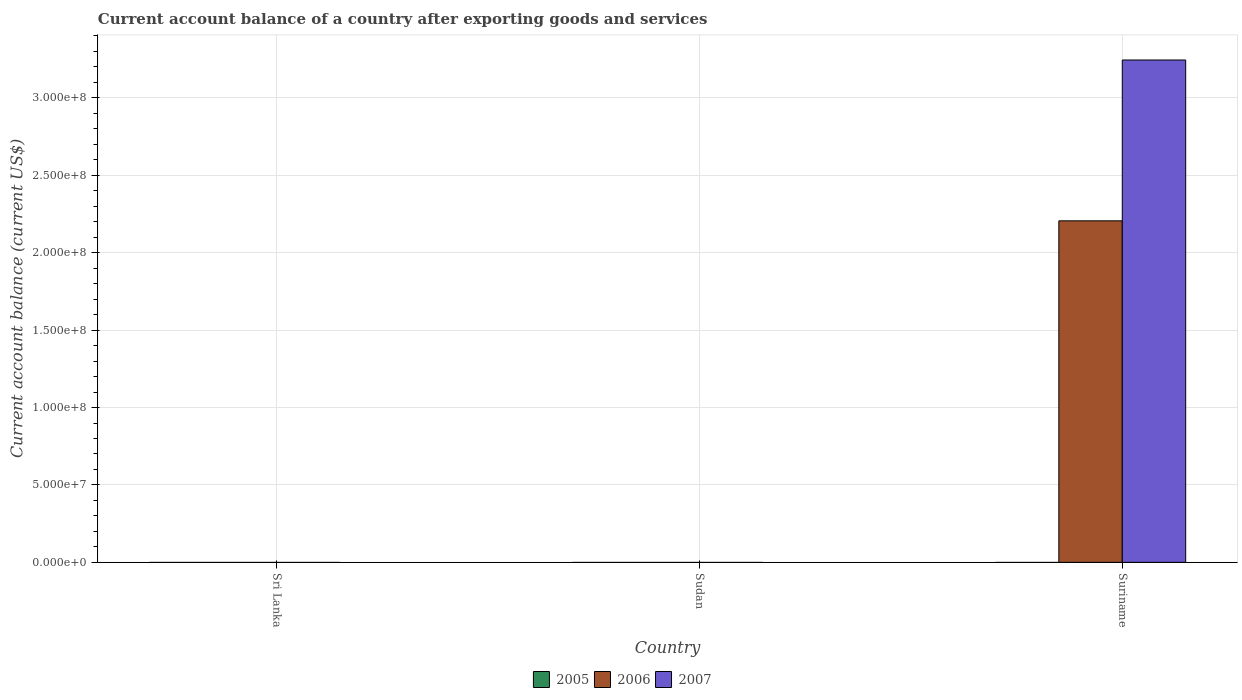How many bars are there on the 2nd tick from the right?
Provide a short and direct response. 0. What is the label of the 3rd group of bars from the left?
Offer a terse response. Suriname. In how many cases, is the number of bars for a given country not equal to the number of legend labels?
Your response must be concise. 3. Across all countries, what is the maximum account balance in 2007?
Give a very brief answer. 3.24e+08. In which country was the account balance in 2006 maximum?
Provide a short and direct response. Suriname. What is the total account balance in 2006 in the graph?
Ensure brevity in your answer.  2.21e+08. What is the difference between the account balance in 2005 in Sri Lanka and the account balance in 2007 in Sudan?
Your answer should be compact. 0. What is the average account balance in 2007 per country?
Give a very brief answer. 1.08e+08. What is the difference between the account balance of/in 2007 and account balance of/in 2006 in Suriname?
Give a very brief answer. 1.04e+08. What is the difference between the highest and the lowest account balance in 2007?
Offer a very short reply. 3.24e+08. In how many countries, is the account balance in 2007 greater than the average account balance in 2007 taken over all countries?
Provide a succinct answer. 1. Is it the case that in every country, the sum of the account balance in 2007 and account balance in 2005 is greater than the account balance in 2006?
Your answer should be very brief. No. How many bars are there?
Ensure brevity in your answer.  2. How many countries are there in the graph?
Keep it short and to the point. 3. What is the difference between two consecutive major ticks on the Y-axis?
Offer a very short reply. 5.00e+07. Does the graph contain grids?
Offer a very short reply. Yes. How are the legend labels stacked?
Make the answer very short. Horizontal. What is the title of the graph?
Provide a short and direct response. Current account balance of a country after exporting goods and services. What is the label or title of the Y-axis?
Provide a short and direct response. Current account balance (current US$). What is the Current account balance (current US$) in 2006 in Sri Lanka?
Provide a succinct answer. 0. What is the Current account balance (current US$) of 2007 in Sri Lanka?
Make the answer very short. 0. What is the Current account balance (current US$) in 2005 in Sudan?
Provide a short and direct response. 0. What is the Current account balance (current US$) in 2006 in Suriname?
Offer a terse response. 2.21e+08. What is the Current account balance (current US$) of 2007 in Suriname?
Make the answer very short. 3.24e+08. Across all countries, what is the maximum Current account balance (current US$) of 2006?
Make the answer very short. 2.21e+08. Across all countries, what is the maximum Current account balance (current US$) in 2007?
Provide a short and direct response. 3.24e+08. Across all countries, what is the minimum Current account balance (current US$) of 2006?
Ensure brevity in your answer.  0. Across all countries, what is the minimum Current account balance (current US$) in 2007?
Provide a short and direct response. 0. What is the total Current account balance (current US$) of 2006 in the graph?
Your answer should be compact. 2.21e+08. What is the total Current account balance (current US$) in 2007 in the graph?
Keep it short and to the point. 3.24e+08. What is the average Current account balance (current US$) in 2006 per country?
Ensure brevity in your answer.  7.35e+07. What is the average Current account balance (current US$) in 2007 per country?
Keep it short and to the point. 1.08e+08. What is the difference between the Current account balance (current US$) of 2006 and Current account balance (current US$) of 2007 in Suriname?
Ensure brevity in your answer.  -1.04e+08. What is the difference between the highest and the lowest Current account balance (current US$) of 2006?
Offer a terse response. 2.21e+08. What is the difference between the highest and the lowest Current account balance (current US$) in 2007?
Your answer should be compact. 3.24e+08. 